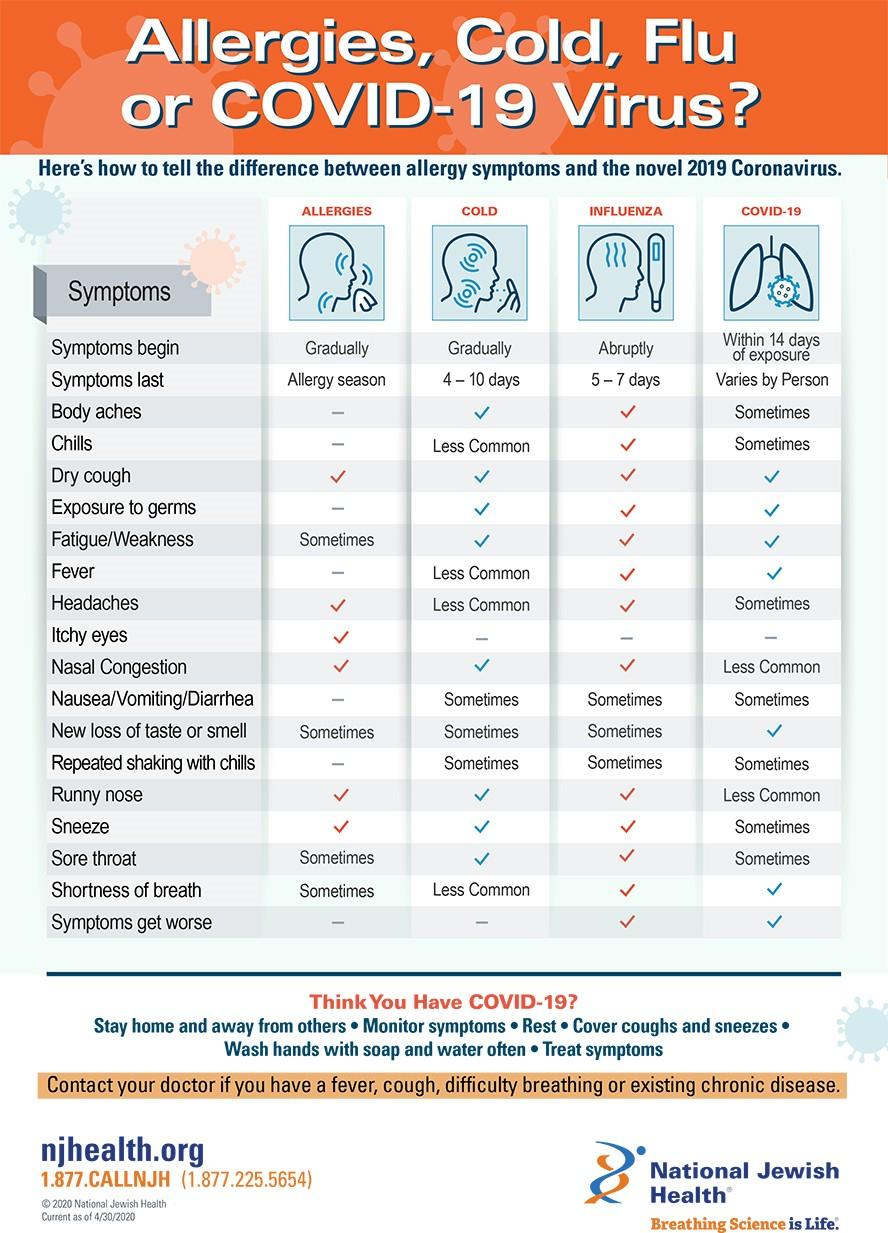Highlight a few significant elements in this photo. Both allergies and the common cold exhibit symptoms that commence gradually. 